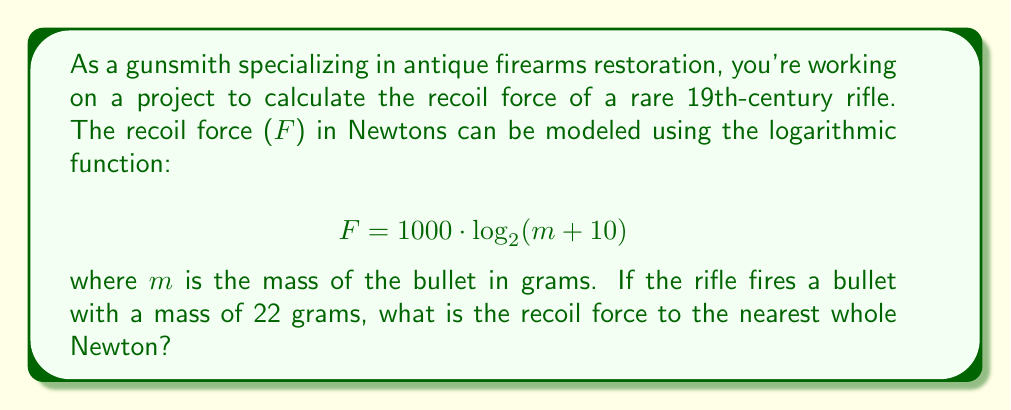Can you solve this math problem? To solve this problem, we need to use the given logarithmic function and substitute the known value for the bullet mass. Let's break it down step-by-step:

1) The given function is:
   $$ F = 1000 \cdot \log_{2}(m + 10) $$

2) We know that the mass of the bullet (m) is 22 grams. Let's substitute this into the equation:
   $$ F = 1000 \cdot \log_{2}(22 + 10) $$

3) Simplify inside the parentheses:
   $$ F = 1000 \cdot \log_{2}(32) $$

4) Now, we need to calculate $\log_{2}(32)$. We can do this by recognizing that $2^5 = 32$, so:
   $$ \log_{2}(32) = 5 $$

5) Substituting this back into our equation:
   $$ F = 1000 \cdot 5 $$

6) Finally, we can calculate the result:
   $$ F = 5000 \text{ Newtons} $$

Since the question asks for the nearest whole Newton, and our result is already a whole number, no further rounding is necessary.
Answer: 5000 Newtons 